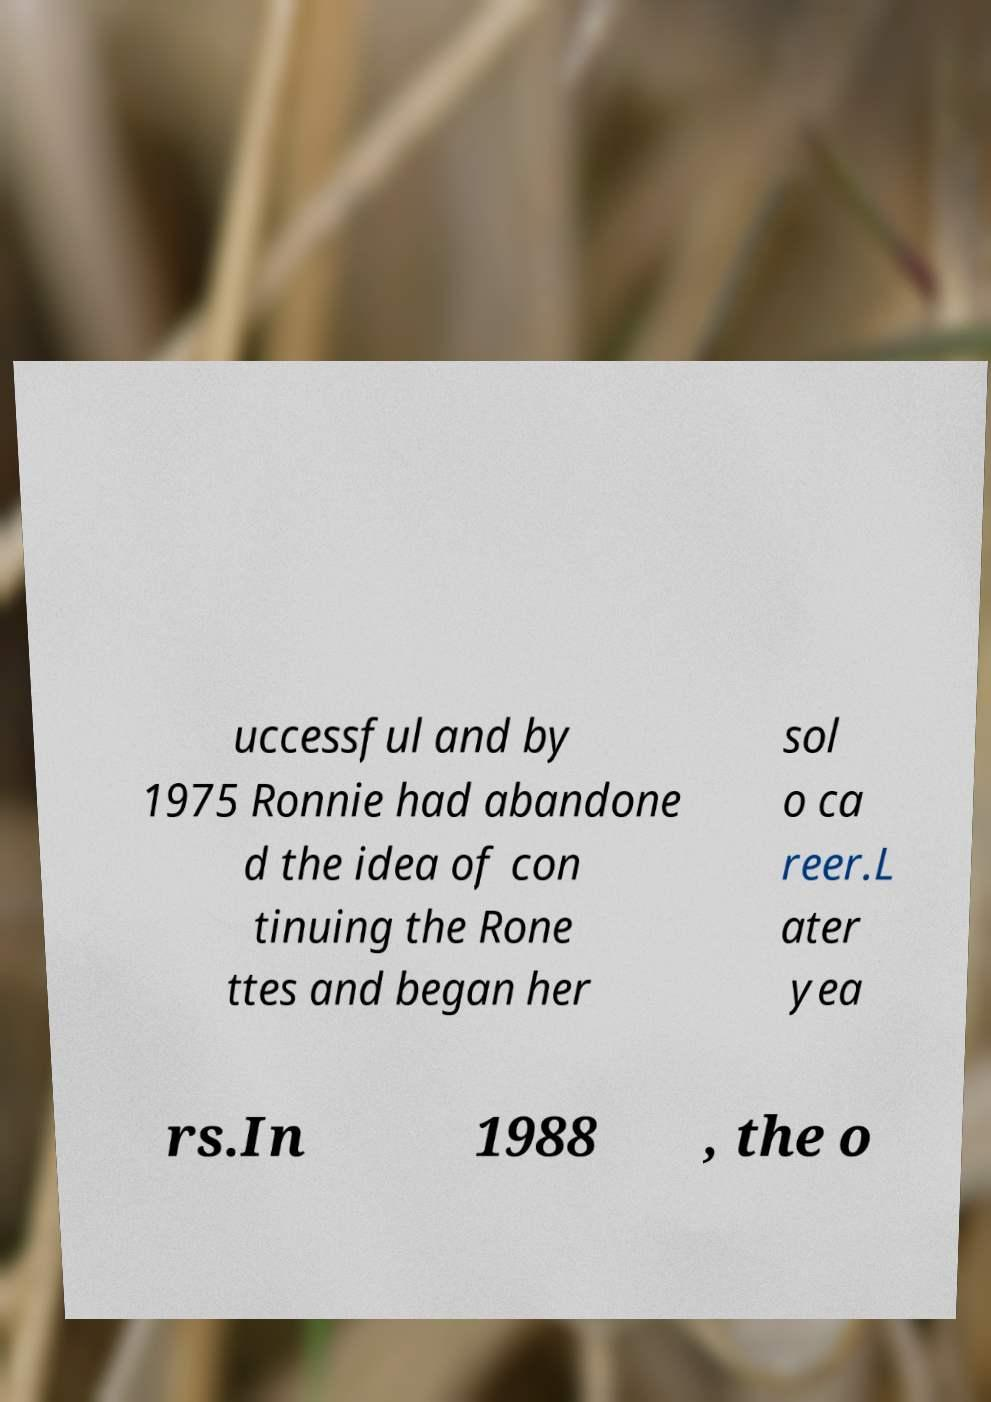What messages or text are displayed in this image? I need them in a readable, typed format. uccessful and by 1975 Ronnie had abandone d the idea of con tinuing the Rone ttes and began her sol o ca reer.L ater yea rs.In 1988 , the o 